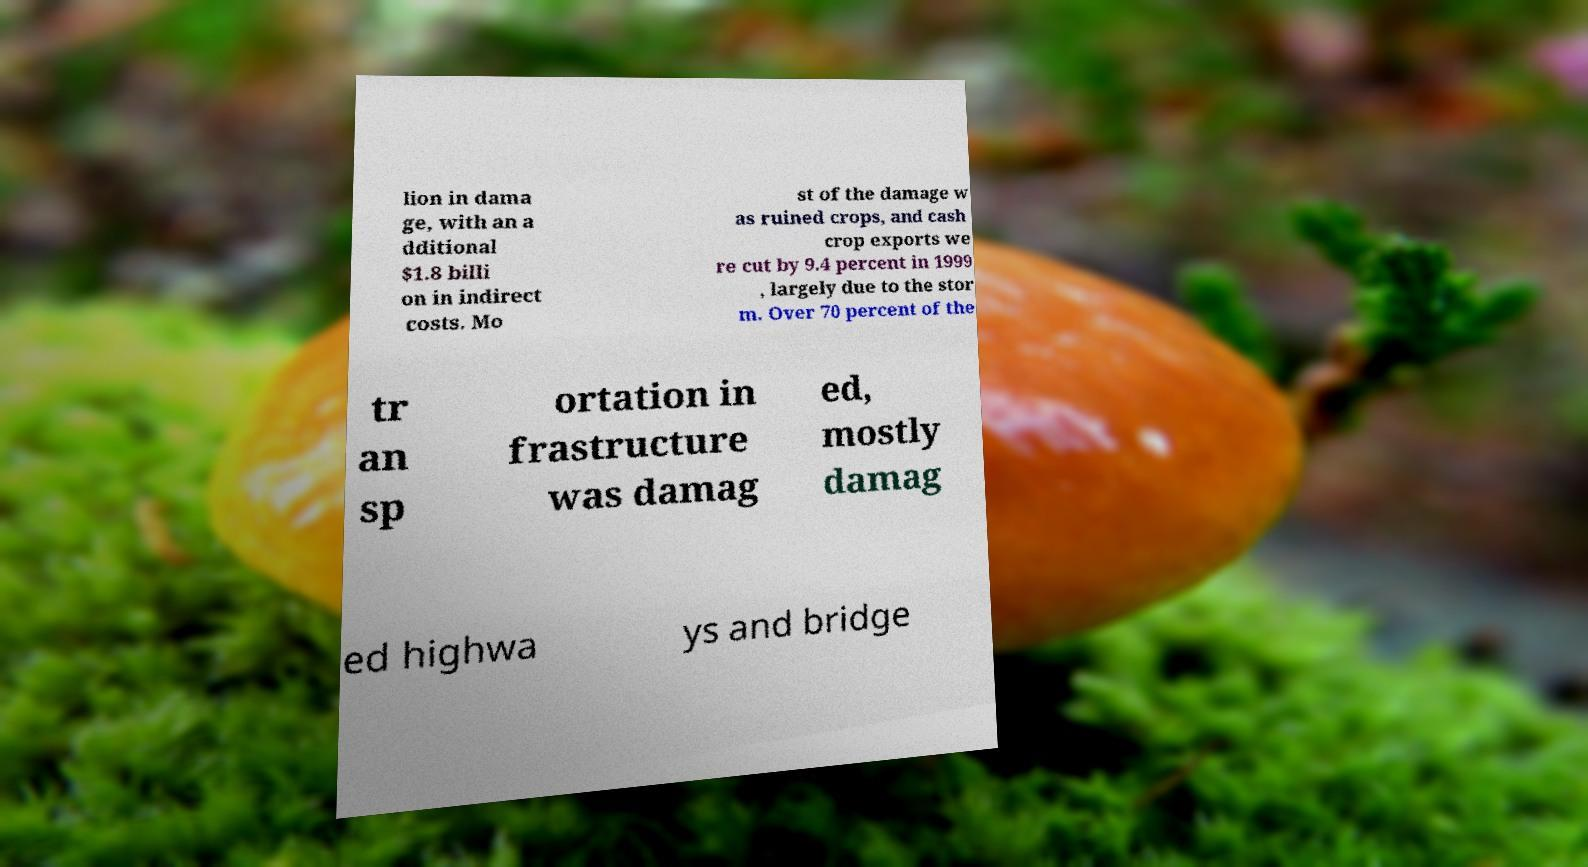I need the written content from this picture converted into text. Can you do that? lion in dama ge, with an a dditional $1.8 billi on in indirect costs. Mo st of the damage w as ruined crops, and cash crop exports we re cut by 9.4 percent in 1999 , largely due to the stor m. Over 70 percent of the tr an sp ortation in frastructure was damag ed, mostly damag ed highwa ys and bridge 